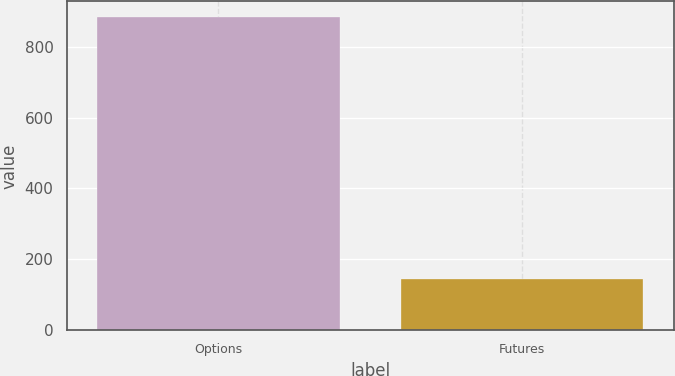Convert chart to OTSL. <chart><loc_0><loc_0><loc_500><loc_500><bar_chart><fcel>Options<fcel>Futures<nl><fcel>883.5<fcel>144.6<nl></chart> 